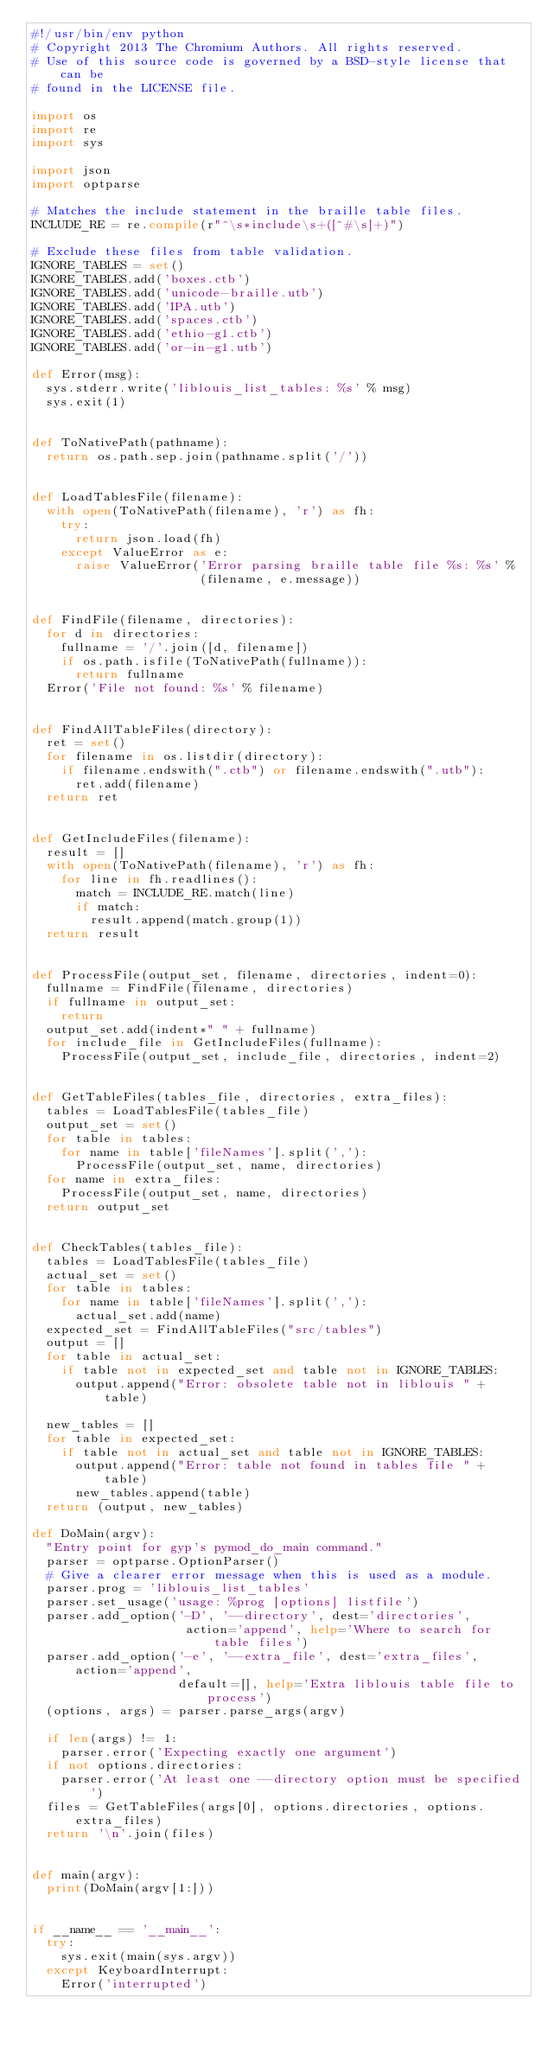<code> <loc_0><loc_0><loc_500><loc_500><_Python_>#!/usr/bin/env python
# Copyright 2013 The Chromium Authors. All rights reserved.
# Use of this source code is governed by a BSD-style license that can be
# found in the LICENSE file.

import os
import re
import sys

import json
import optparse

# Matches the include statement in the braille table files.
INCLUDE_RE = re.compile(r"^\s*include\s+([^#\s]+)")

# Exclude these files from table validation.
IGNORE_TABLES = set()
IGNORE_TABLES.add('boxes.ctb')
IGNORE_TABLES.add('unicode-braille.utb')
IGNORE_TABLES.add('IPA.utb')
IGNORE_TABLES.add('spaces.ctb')
IGNORE_TABLES.add('ethio-g1.ctb')
IGNORE_TABLES.add('or-in-g1.utb')

def Error(msg):
  sys.stderr.write('liblouis_list_tables: %s' % msg)
  sys.exit(1)


def ToNativePath(pathname):
  return os.path.sep.join(pathname.split('/'))


def LoadTablesFile(filename):
  with open(ToNativePath(filename), 'r') as fh:
    try:
      return json.load(fh)
    except ValueError as e:
      raise ValueError('Error parsing braille table file %s: %s' %
                       (filename, e.message))


def FindFile(filename, directories):
  for d in directories:
    fullname = '/'.join([d, filename])
    if os.path.isfile(ToNativePath(fullname)):
      return fullname
  Error('File not found: %s' % filename)


def FindAllTableFiles(directory):
  ret = set()
  for filename in os.listdir(directory):
    if filename.endswith(".ctb") or filename.endswith(".utb"):
      ret.add(filename)
  return ret


def GetIncludeFiles(filename):
  result = []
  with open(ToNativePath(filename), 'r') as fh:
    for line in fh.readlines():
      match = INCLUDE_RE.match(line)
      if match:
        result.append(match.group(1))
  return result


def ProcessFile(output_set, filename, directories, indent=0):
  fullname = FindFile(filename, directories)
  if fullname in output_set:
    return
  output_set.add(indent*" " + fullname)
  for include_file in GetIncludeFiles(fullname):
    ProcessFile(output_set, include_file, directories, indent=2)


def GetTableFiles(tables_file, directories, extra_files):
  tables = LoadTablesFile(tables_file)
  output_set = set()
  for table in tables:
    for name in table['fileNames'].split(','):
      ProcessFile(output_set, name, directories)
  for name in extra_files:
    ProcessFile(output_set, name, directories)
  return output_set


def CheckTables(tables_file):
  tables = LoadTablesFile(tables_file)
  actual_set = set()
  for table in tables:
    for name in table['fileNames'].split(','):
      actual_set.add(name)
  expected_set = FindAllTableFiles("src/tables")
  output = []
  for table in actual_set:
    if table not in expected_set and table not in IGNORE_TABLES:
      output.append("Error: obsolete table not in liblouis " + table)

  new_tables = []
  for table in expected_set:
    if table not in actual_set and table not in IGNORE_TABLES:
      output.append("Error: table not found in tables file " + table)
      new_tables.append(table)
  return (output, new_tables)

def DoMain(argv):
  "Entry point for gyp's pymod_do_main command."
  parser = optparse.OptionParser()
  # Give a clearer error message when this is used as a module.
  parser.prog = 'liblouis_list_tables'
  parser.set_usage('usage: %prog [options] listfile')
  parser.add_option('-D', '--directory', dest='directories',
                     action='append', help='Where to search for table files')
  parser.add_option('-e', '--extra_file', dest='extra_files', action='append',
                    default=[], help='Extra liblouis table file to process')
  (options, args) = parser.parse_args(argv)

  if len(args) != 1:
    parser.error('Expecting exactly one argument')
  if not options.directories:
    parser.error('At least one --directory option must be specified')
  files = GetTableFiles(args[0], options.directories, options.extra_files)
  return '\n'.join(files)


def main(argv):
  print(DoMain(argv[1:]))


if __name__ == '__main__':
  try:
    sys.exit(main(sys.argv))
  except KeyboardInterrupt:
    Error('interrupted')
</code> 